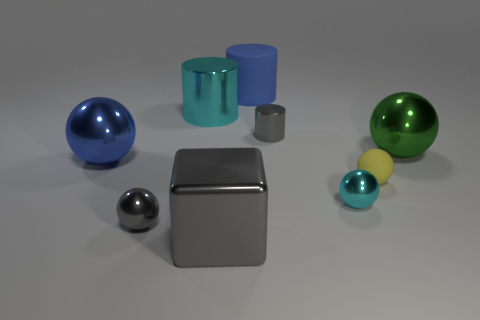Add 1 large cylinders. How many objects exist? 10 Subtract all tiny gray balls. How many balls are left? 4 Subtract all cyan spheres. How many spheres are left? 4 Subtract 1 cylinders. How many cylinders are left? 2 Subtract all big brown balls. Subtract all cyan shiny things. How many objects are left? 7 Add 5 large metallic objects. How many large metallic objects are left? 9 Add 3 tiny blue metal cubes. How many tiny blue metal cubes exist? 3 Subtract 0 yellow cubes. How many objects are left? 9 Subtract all blocks. How many objects are left? 8 Subtract all purple cylinders. Subtract all blue blocks. How many cylinders are left? 3 